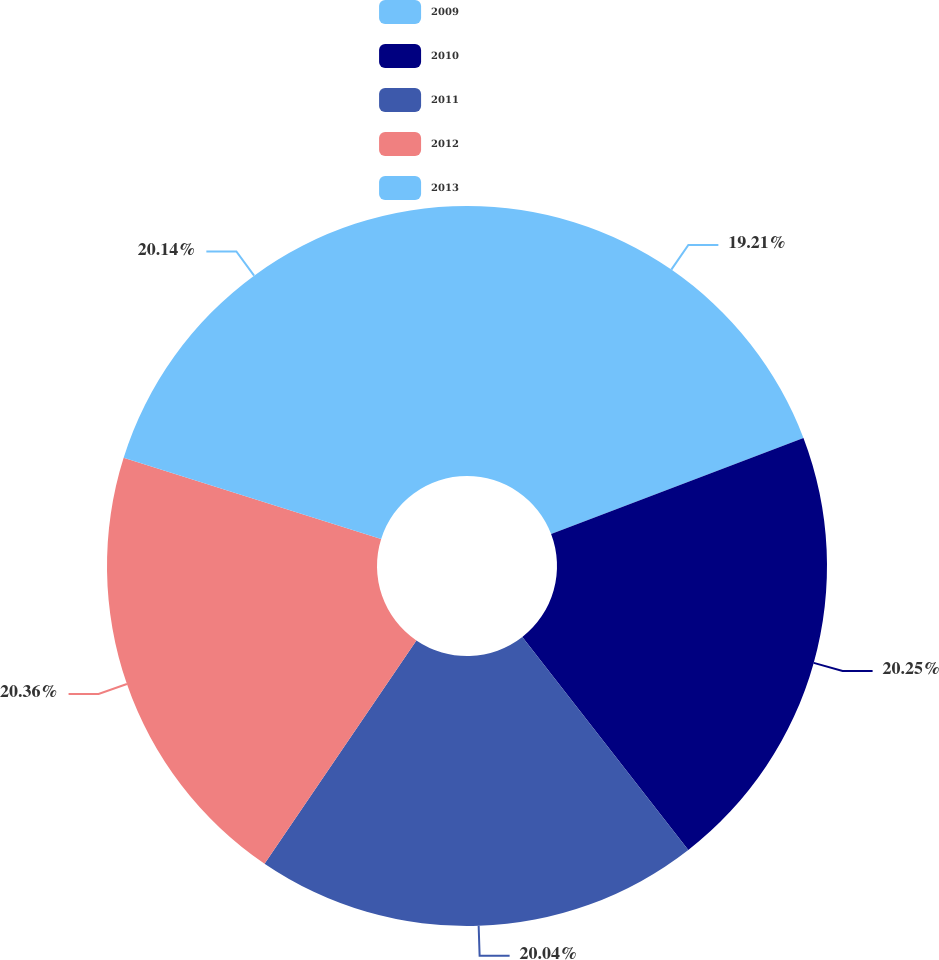Convert chart. <chart><loc_0><loc_0><loc_500><loc_500><pie_chart><fcel>2009<fcel>2010<fcel>2011<fcel>2012<fcel>2013<nl><fcel>19.21%<fcel>20.25%<fcel>20.04%<fcel>20.35%<fcel>20.14%<nl></chart> 